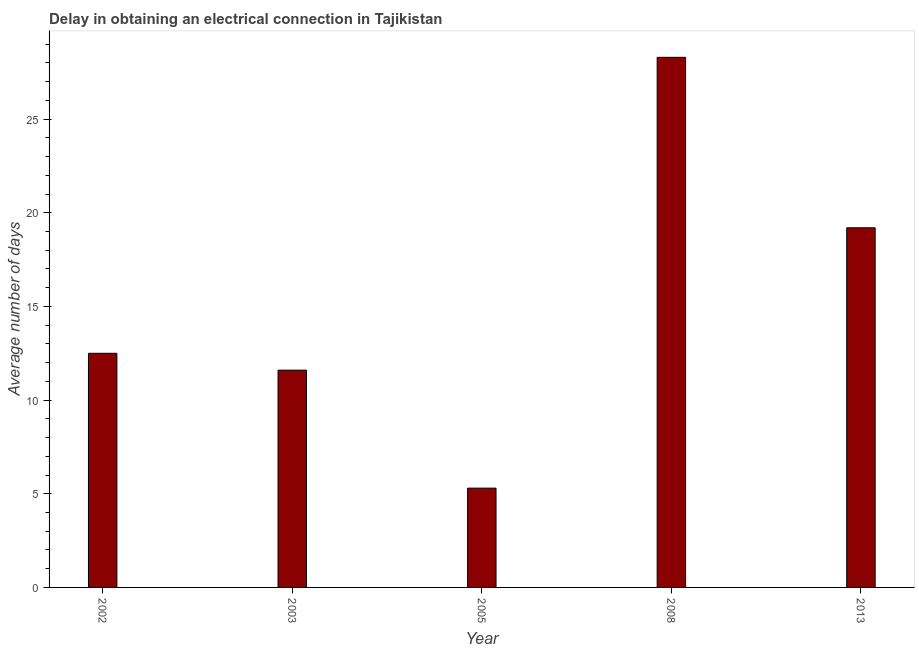Does the graph contain grids?
Offer a terse response. No. What is the title of the graph?
Your answer should be very brief. Delay in obtaining an electrical connection in Tajikistan. What is the label or title of the X-axis?
Offer a very short reply. Year. What is the label or title of the Y-axis?
Your answer should be compact. Average number of days. What is the dalay in electrical connection in 2008?
Provide a succinct answer. 28.3. Across all years, what is the maximum dalay in electrical connection?
Provide a short and direct response. 28.3. Across all years, what is the minimum dalay in electrical connection?
Your answer should be very brief. 5.3. What is the sum of the dalay in electrical connection?
Your answer should be compact. 76.9. What is the difference between the dalay in electrical connection in 2003 and 2008?
Give a very brief answer. -16.7. What is the average dalay in electrical connection per year?
Your answer should be very brief. 15.38. What is the median dalay in electrical connection?
Provide a short and direct response. 12.5. In how many years, is the dalay in electrical connection greater than 6 days?
Provide a short and direct response. 4. What is the ratio of the dalay in electrical connection in 2005 to that in 2013?
Offer a very short reply. 0.28. Is the dalay in electrical connection in 2002 less than that in 2005?
Provide a short and direct response. No. Is the difference between the dalay in electrical connection in 2008 and 2013 greater than the difference between any two years?
Your answer should be compact. No. What is the difference between the highest and the lowest dalay in electrical connection?
Your answer should be very brief. 23. Are all the bars in the graph horizontal?
Keep it short and to the point. No. What is the difference between two consecutive major ticks on the Y-axis?
Make the answer very short. 5. Are the values on the major ticks of Y-axis written in scientific E-notation?
Your answer should be very brief. No. What is the Average number of days in 2003?
Provide a short and direct response. 11.6. What is the Average number of days of 2008?
Make the answer very short. 28.3. What is the Average number of days in 2013?
Provide a short and direct response. 19.2. What is the difference between the Average number of days in 2002 and 2003?
Make the answer very short. 0.9. What is the difference between the Average number of days in 2002 and 2005?
Keep it short and to the point. 7.2. What is the difference between the Average number of days in 2002 and 2008?
Offer a very short reply. -15.8. What is the difference between the Average number of days in 2003 and 2008?
Keep it short and to the point. -16.7. What is the difference between the Average number of days in 2005 and 2008?
Offer a very short reply. -23. What is the difference between the Average number of days in 2005 and 2013?
Ensure brevity in your answer.  -13.9. What is the ratio of the Average number of days in 2002 to that in 2003?
Offer a very short reply. 1.08. What is the ratio of the Average number of days in 2002 to that in 2005?
Your answer should be compact. 2.36. What is the ratio of the Average number of days in 2002 to that in 2008?
Make the answer very short. 0.44. What is the ratio of the Average number of days in 2002 to that in 2013?
Provide a succinct answer. 0.65. What is the ratio of the Average number of days in 2003 to that in 2005?
Offer a terse response. 2.19. What is the ratio of the Average number of days in 2003 to that in 2008?
Offer a terse response. 0.41. What is the ratio of the Average number of days in 2003 to that in 2013?
Give a very brief answer. 0.6. What is the ratio of the Average number of days in 2005 to that in 2008?
Provide a short and direct response. 0.19. What is the ratio of the Average number of days in 2005 to that in 2013?
Make the answer very short. 0.28. What is the ratio of the Average number of days in 2008 to that in 2013?
Your answer should be compact. 1.47. 